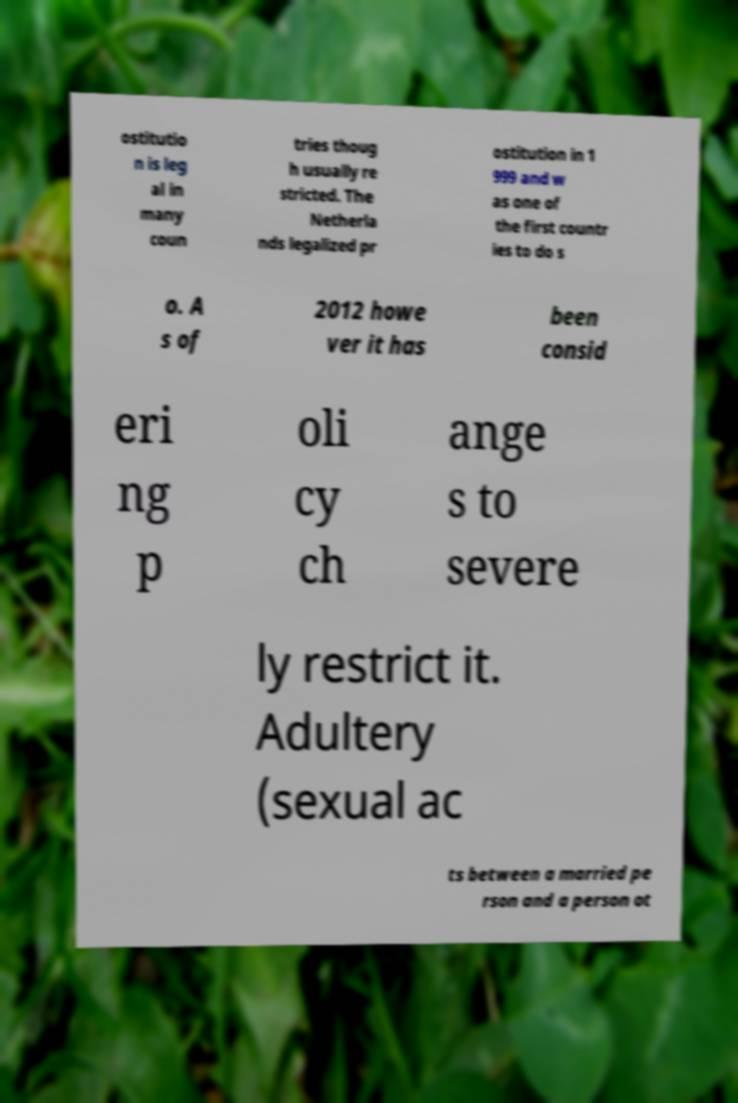Please read and relay the text visible in this image. What does it say? ostitutio n is leg al in many coun tries thoug h usually re stricted. The Netherla nds legalized pr ostitution in 1 999 and w as one of the first countr ies to do s o. A s of 2012 howe ver it has been consid eri ng p oli cy ch ange s to severe ly restrict it. Adultery (sexual ac ts between a married pe rson and a person ot 